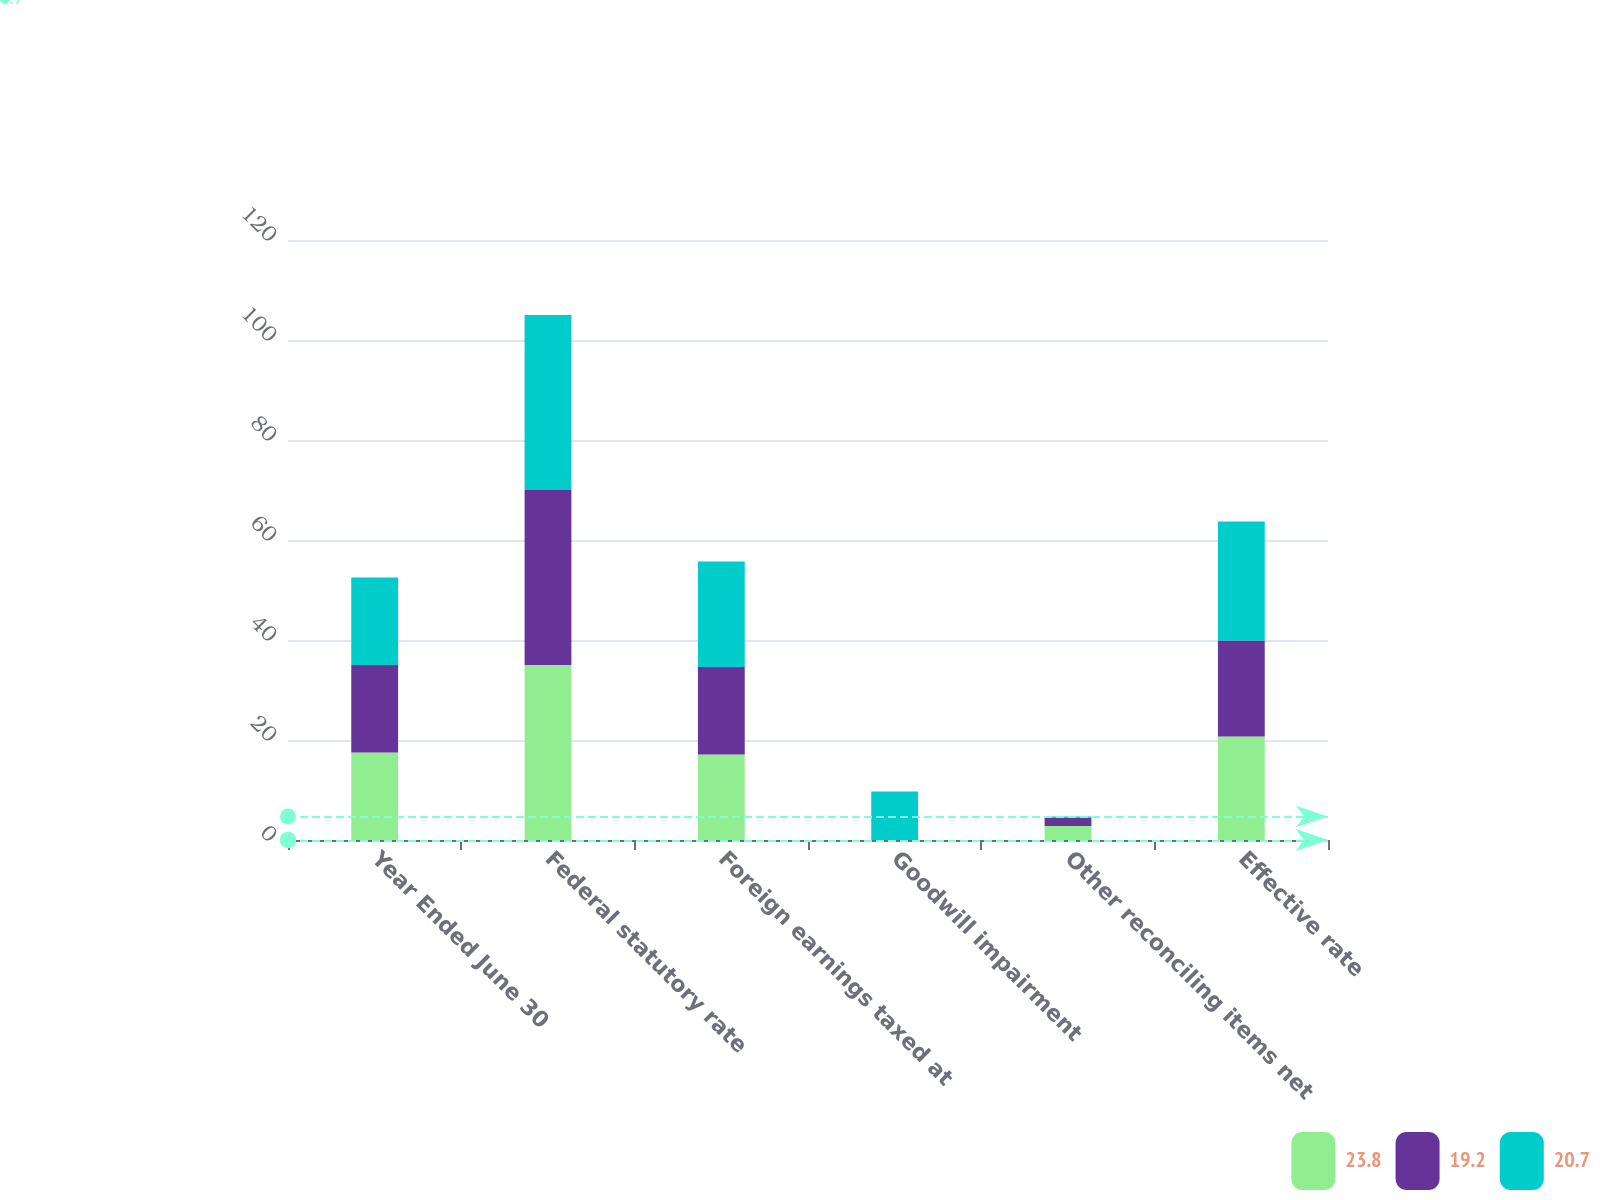<chart> <loc_0><loc_0><loc_500><loc_500><stacked_bar_chart><ecel><fcel>Year Ended June 30<fcel>Federal statutory rate<fcel>Foreign earnings taxed at<fcel>Goodwill impairment<fcel>Other reconciling items net<fcel>Effective rate<nl><fcel>23.8<fcel>17.5<fcel>35<fcel>17.1<fcel>0<fcel>2.8<fcel>20.7<nl><fcel>19.2<fcel>17.5<fcel>35<fcel>17.5<fcel>0<fcel>1.7<fcel>19.2<nl><fcel>20.7<fcel>17.5<fcel>35<fcel>21.1<fcel>9.7<fcel>0.2<fcel>23.8<nl></chart> 